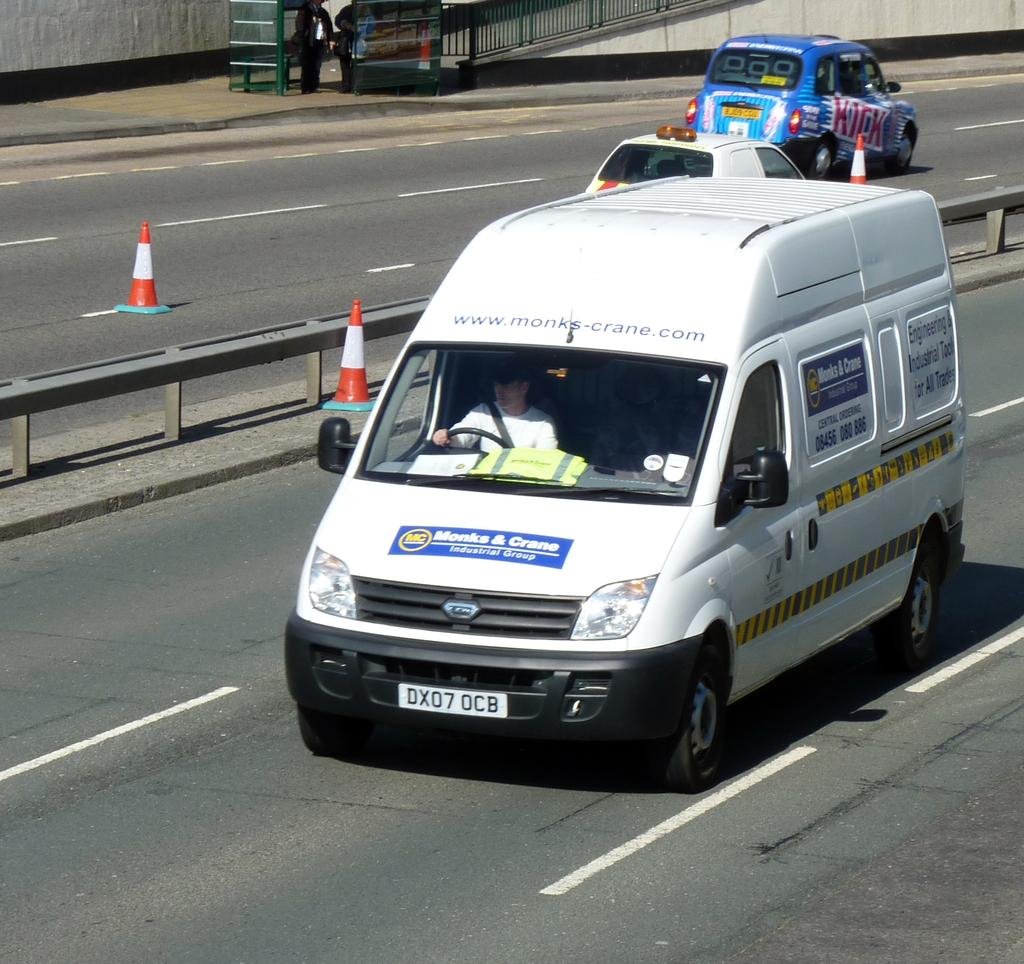<image>
Summarize the visual content of the image. a van with the letters DX07 on the front 